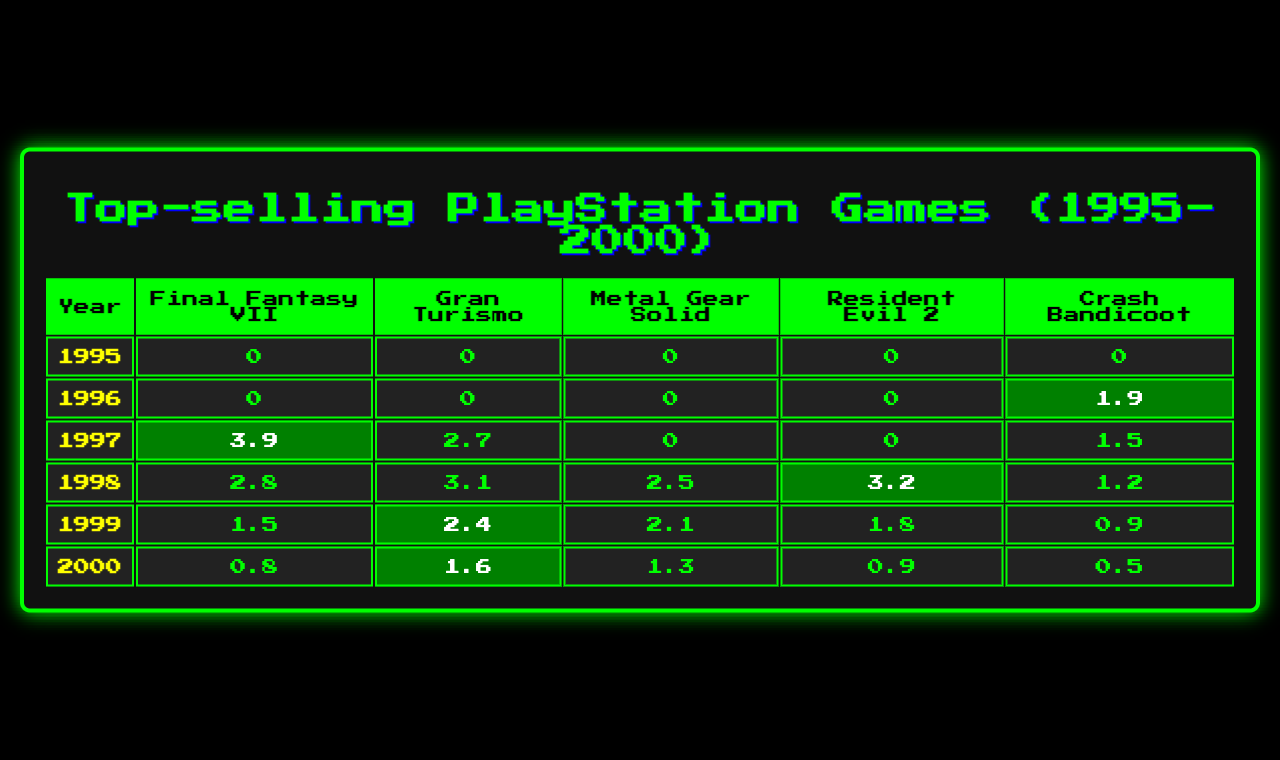What year had the highest sales for Final Fantasy VII? The highest sales for Final Fantasy VII can be found by looking at its sales figures for each year. In 1997, it had 3.9 million sales, which is higher than any other year.
Answer: 1997 What was the sales figure for Crash Bandicoot in 1996? The table shows that in 1996, Crash Bandicoot had sales of 1.9 million copies.
Answer: 1.9 million Which game had the lowest sales in 1999? To find the lowest sales in 1999, we check each game's sales: Final Fantasy VII (1.5), Gran Turismo (2.4), Metal Gear Solid (2.1), Resident Evil 2 (1.8), and Crash Bandicoot (0.9). Crash Bandicoot had the lowest at 0.9 million.
Answer: Crash Bandicoot What is the total sales figure for Gran Turismo from 1997 to 2000? Gran Turismo had sales of 2.7 (1997), 3.1 (1998), 2.4 (1999), and 1.6 (2000). Adding those figures gives 2.7 + 3.1 + 2.4 + 1.6 = 10.8 million.
Answer: 10.8 million Did Resident Evil 2 ever have zero sales? Reviewing the sales figures for Resident Evil 2, we see that it had zero sales in 1997 and 1996, indicating that yes, it did have zero sales in those years.
Answer: Yes Which game had the highest sales in the year 1998? By inspecting the sales figures for 1998: Final Fantasy VII (2.8), Gran Turismo (3.1), Metal Gear Solid (2.5), Resident Evil 2 (3.2), and Crash Bandicoot (1.2), Resident Evil 2 had the highest sales at 3.2 million.
Answer: Resident Evil 2 Compare the total sales of Final Fantasy VII and Metal Gear Solid from 1995 to 2000. The total sales for Final Fantasy VII is 3.9 (1997) + 2.8 (1998) + 1.5 (1999) + 0.8 (2000) = 8 million. For Metal Gear Solid, total is 0 (1995) + 0 (1996) + 0 (1997) + 2.5 (1998) + 2.1 (1999) + 1.3 (2000) = 5.9 million. Comparing them, Final Fantasy VII has higher total sales.
Answer: Final Fantasy VII What year saw an increase in sales for Crash Bandicoot compared to the previous year? Examining Crash Bandicoot's sales: 1.9 (1996), 1.5 (1997), 1.2 (1998), 0.9 (1999), and 0.5 (2000), the only year with an increase compared to the previous year is 1996 compared to 1995, where it was 0.
Answer: 1996 In what year did Metal Gear Solid have its first recorded sales? Looking through the sales figures, Metal Gear Solid had its first recorded sales in 1998 with 2.5 million, following no sales in the preceding years.
Answer: 1998 Which game had consistent sales from 1995 to 2000 without dropping to zero? Reviewing the sales of each game, only Crash Bandicoot had sales figures in every year from 1996 onward (1.9, 1.5, 1.2, 0.9, 0.5), with no recorded zeros after 1995.
Answer: Crash Bandicoot 